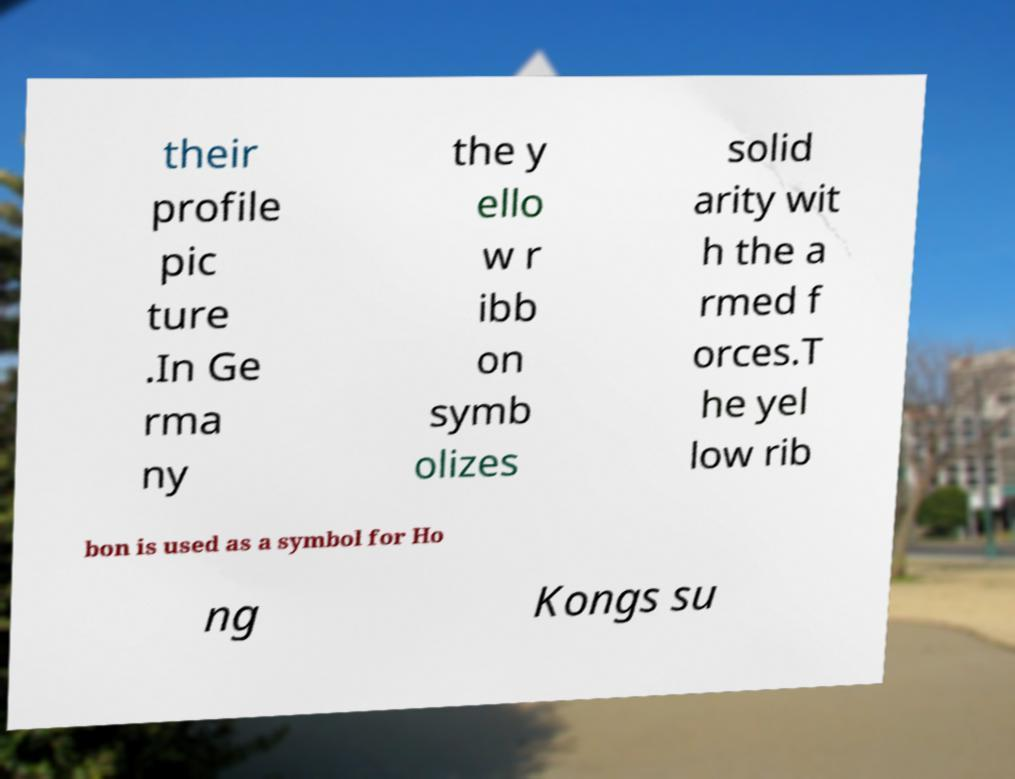I need the written content from this picture converted into text. Can you do that? their profile pic ture .In Ge rma ny the y ello w r ibb on symb olizes solid arity wit h the a rmed f orces.T he yel low rib bon is used as a symbol for Ho ng Kongs su 